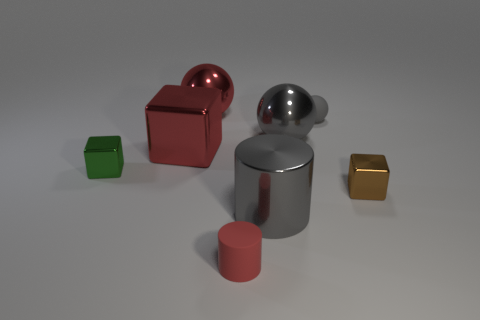Subtract all big metallic spheres. How many spheres are left? 1 Add 2 large metal cubes. How many objects exist? 10 Subtract all cubes. How many objects are left? 5 Subtract 0 purple blocks. How many objects are left? 8 Subtract all purple rubber cubes. Subtract all green objects. How many objects are left? 7 Add 3 large metallic balls. How many large metallic balls are left? 5 Add 2 tiny red cylinders. How many tiny red cylinders exist? 3 